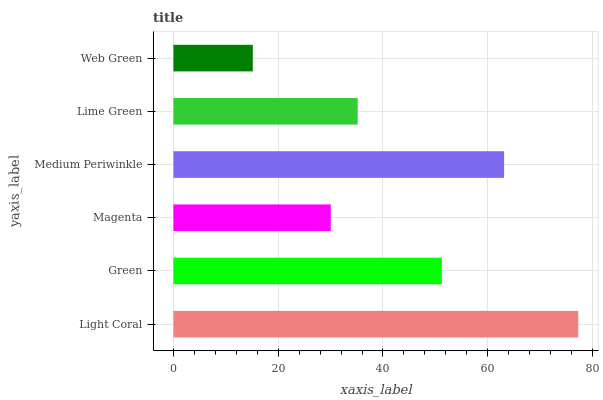Is Web Green the minimum?
Answer yes or no. Yes. Is Light Coral the maximum?
Answer yes or no. Yes. Is Green the minimum?
Answer yes or no. No. Is Green the maximum?
Answer yes or no. No. Is Light Coral greater than Green?
Answer yes or no. Yes. Is Green less than Light Coral?
Answer yes or no. Yes. Is Green greater than Light Coral?
Answer yes or no. No. Is Light Coral less than Green?
Answer yes or no. No. Is Green the high median?
Answer yes or no. Yes. Is Lime Green the low median?
Answer yes or no. Yes. Is Magenta the high median?
Answer yes or no. No. Is Medium Periwinkle the low median?
Answer yes or no. No. 